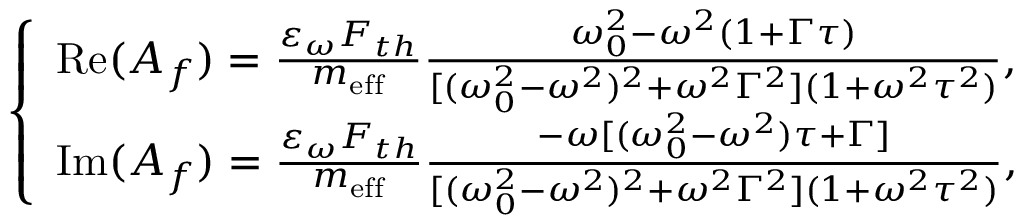<formula> <loc_0><loc_0><loc_500><loc_500>\left \{ \begin{array} { l l } { R e ( A _ { f } ) = \frac { \varepsilon _ { \omega } F _ { t h } } { m _ { e f f } } \frac { \omega _ { 0 } ^ { 2 } - \omega ^ { 2 } ( 1 + \Gamma \tau ) } { [ ( \omega _ { 0 } ^ { 2 } - \omega ^ { 2 } ) ^ { 2 } + \omega ^ { 2 } \Gamma ^ { 2 } ] ( 1 + \omega ^ { 2 } \tau ^ { 2 } ) } , } \\ { I m ( A _ { f } ) = \frac { \varepsilon _ { \omega } F _ { t h } } { m _ { e f f } } \frac { - \omega [ ( \omega _ { 0 } ^ { 2 } - \omega ^ { 2 } ) \tau + \Gamma ] } { [ ( \omega _ { 0 } ^ { 2 } - \omega ^ { 2 } ) ^ { 2 } + \omega ^ { 2 } \Gamma ^ { 2 } ] ( 1 + \omega ^ { 2 } \tau ^ { 2 } ) } , } \end{array}</formula> 